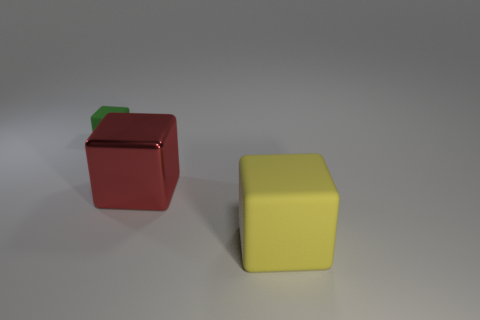Add 1 big gray metallic balls. How many objects exist? 4 Add 3 large yellow rubber blocks. How many large yellow rubber blocks are left? 4 Add 1 blue rubber balls. How many blue rubber balls exist? 1 Subtract 1 red cubes. How many objects are left? 2 Subtract all tiny matte things. Subtract all green rubber objects. How many objects are left? 1 